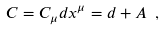Convert formula to latex. <formula><loc_0><loc_0><loc_500><loc_500>C = C _ { \mu } d x ^ { \mu } = d + A \ ,</formula> 